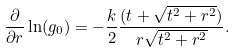<formula> <loc_0><loc_0><loc_500><loc_500>\frac { \partial } { \partial r } \ln ( g _ { 0 } ) = - \frac { k } { 2 } \frac { ( t + \sqrt { t ^ { 2 } + r ^ { 2 } } ) } { r \sqrt { t ^ { 2 } + r ^ { 2 } } } .</formula> 